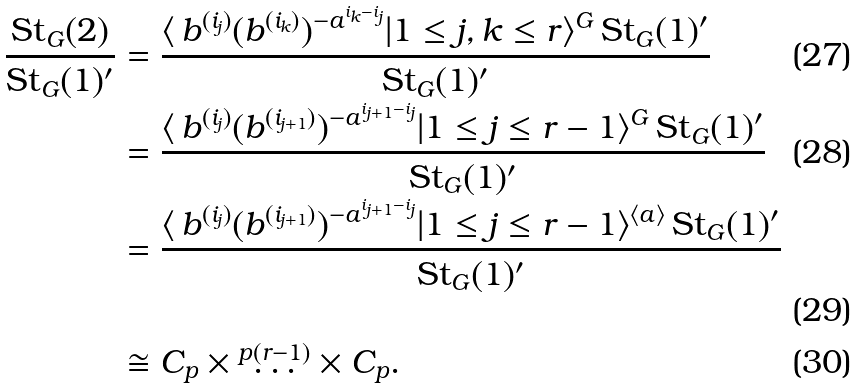Convert formula to latex. <formula><loc_0><loc_0><loc_500><loc_500>\frac { \text {St} _ { G } ( 2 ) } { \text {St} _ { G } ( 1 ) ^ { \prime } } & = \frac { \langle \, b ^ { ( i _ { j } ) } ( b ^ { ( i _ { k } ) } ) ^ { - a ^ { i _ { k } - i _ { j } } } | 1 \leq j , k \leq r \rangle ^ { G } \, \text {St} _ { G } ( 1 ) ^ { \prime } } { \text {St} _ { G } ( 1 ) ^ { \prime } } \\ & = \frac { \langle \, b ^ { ( i _ { j } ) } ( b ^ { ( i _ { j + 1 } ) } ) ^ { - a ^ { i _ { j + 1 } - i _ { j } } } | 1 \leq j \leq r - 1 \rangle ^ { G } \, \text {St} _ { G } ( 1 ) ^ { \prime } } { \text {St} _ { G } ( 1 ) ^ { \prime } } \\ & = \frac { \langle \, b ^ { ( i _ { j } ) } ( b ^ { ( i _ { j + 1 } ) } ) ^ { - a ^ { i _ { j + 1 } - i _ { j } } } | 1 \leq j \leq r - 1 \rangle ^ { \langle a \rangle } \, \text {St} _ { G } ( 1 ) ^ { \prime } } { \text {St} _ { G } ( 1 ) ^ { \prime } } \\ & \cong C _ { p } \times \overset { p ( r - 1 ) } \dots \times C _ { p } .</formula> 